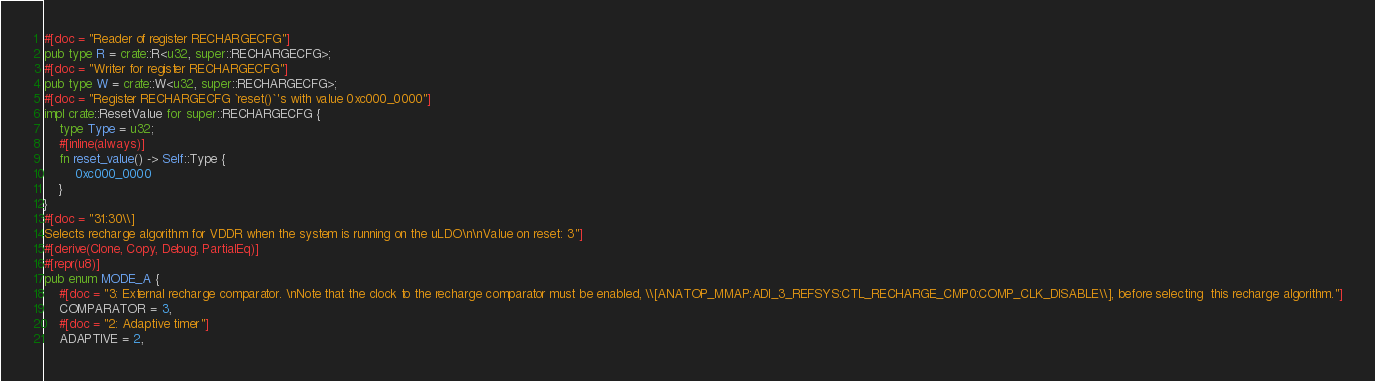Convert code to text. <code><loc_0><loc_0><loc_500><loc_500><_Rust_>#[doc = "Reader of register RECHARGECFG"]
pub type R = crate::R<u32, super::RECHARGECFG>;
#[doc = "Writer for register RECHARGECFG"]
pub type W = crate::W<u32, super::RECHARGECFG>;
#[doc = "Register RECHARGECFG `reset()`'s with value 0xc000_0000"]
impl crate::ResetValue for super::RECHARGECFG {
    type Type = u32;
    #[inline(always)]
    fn reset_value() -> Self::Type {
        0xc000_0000
    }
}
#[doc = "31:30\\]
Selects recharge algorithm for VDDR when the system is running on the uLDO\n\nValue on reset: 3"]
#[derive(Clone, Copy, Debug, PartialEq)]
#[repr(u8)]
pub enum MODE_A {
    #[doc = "3: External recharge comparator. \nNote that the clock to the recharge comparator must be enabled, \\[ANATOP_MMAP:ADI_3_REFSYS:CTL_RECHARGE_CMP0:COMP_CLK_DISABLE\\], before selecting  this recharge algorithm."]
    COMPARATOR = 3,
    #[doc = "2: Adaptive timer"]
    ADAPTIVE = 2,</code> 